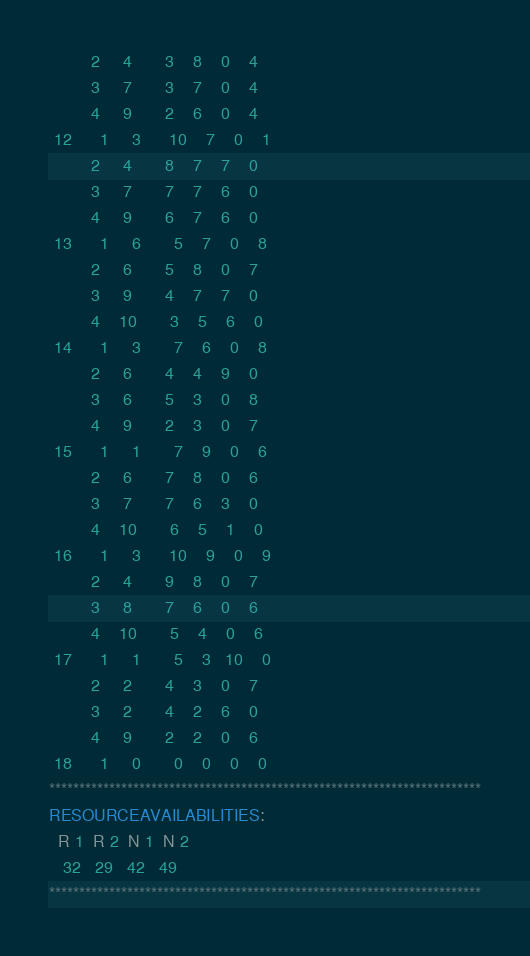Convert code to text. <code><loc_0><loc_0><loc_500><loc_500><_ObjectiveC_>         2     4       3    8    0    4
         3     7       3    7    0    4
         4     9       2    6    0    4
 12      1     3      10    7    0    1
         2     4       8    7    7    0
         3     7       7    7    6    0
         4     9       6    7    6    0
 13      1     6       5    7    0    8
         2     6       5    8    0    7
         3     9       4    7    7    0
         4    10       3    5    6    0
 14      1     3       7    6    0    8
         2     6       4    4    9    0
         3     6       5    3    0    8
         4     9       2    3    0    7
 15      1     1       7    9    0    6
         2     6       7    8    0    6
         3     7       7    6    3    0
         4    10       6    5    1    0
 16      1     3      10    9    0    9
         2     4       9    8    0    7
         3     8       7    6    0    6
         4    10       5    4    0    6
 17      1     1       5    3   10    0
         2     2       4    3    0    7
         3     2       4    2    6    0
         4     9       2    2    0    6
 18      1     0       0    0    0    0
************************************************************************
RESOURCEAVAILABILITIES:
  R 1  R 2  N 1  N 2
   32   29   42   49
************************************************************************
</code> 